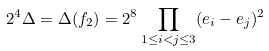<formula> <loc_0><loc_0><loc_500><loc_500>2 ^ { 4 } \Delta = \Delta ( f _ { 2 } ) = 2 ^ { 8 } \prod _ { 1 \leq i < j \leq 3 } ( e _ { i } - e _ { j } ) ^ { 2 }</formula> 